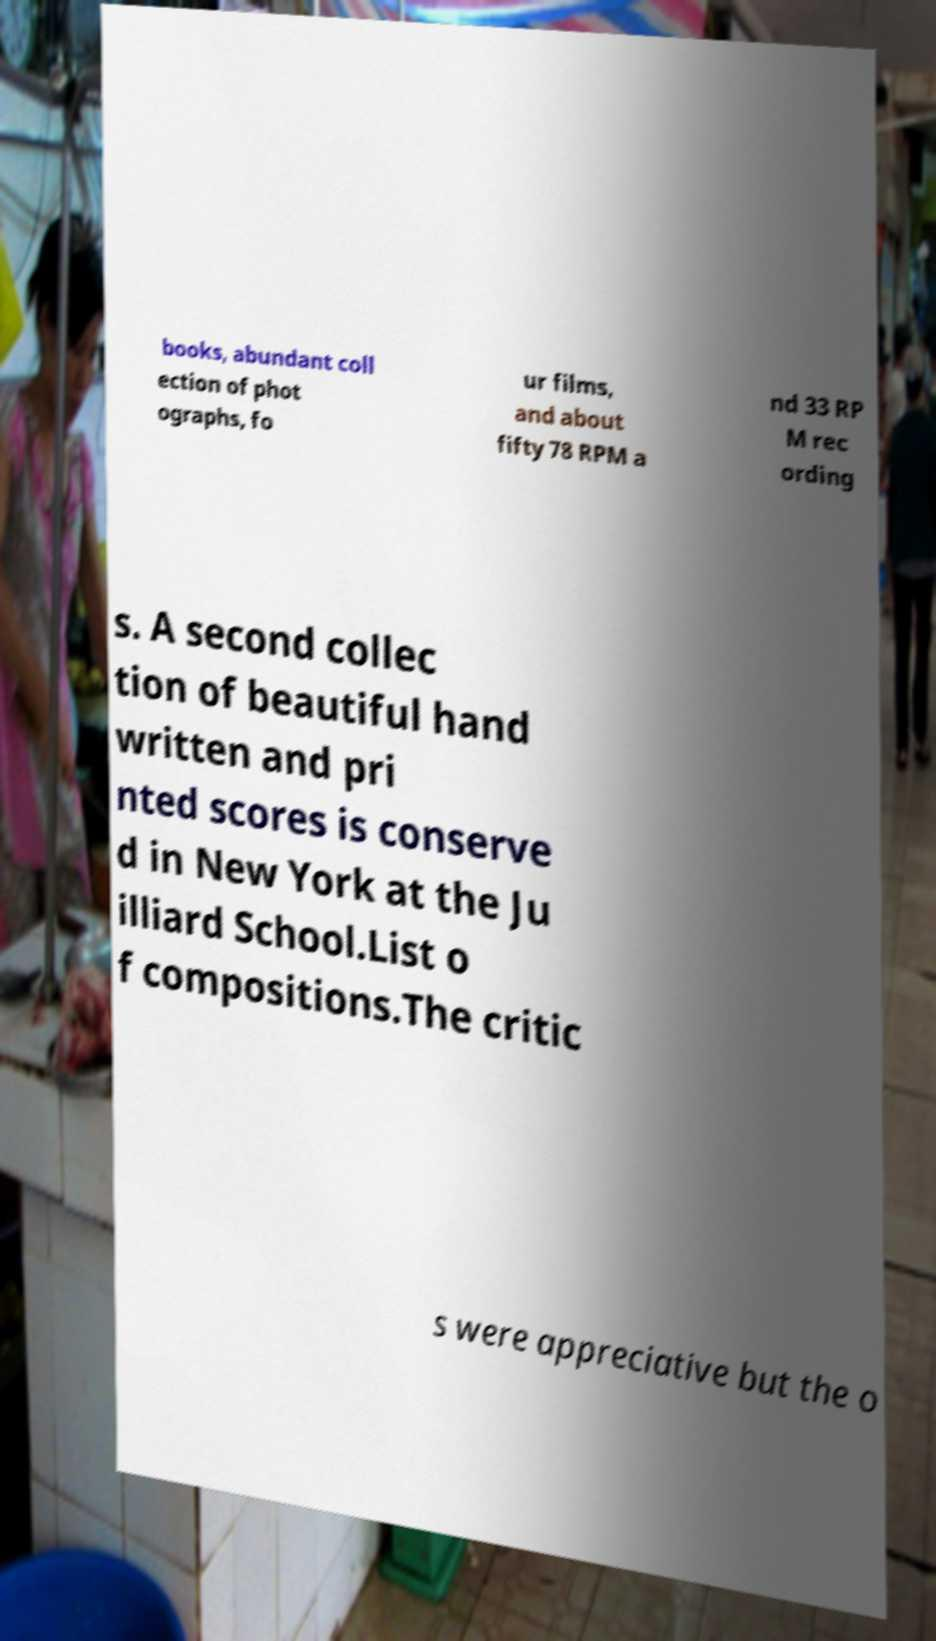For documentation purposes, I need the text within this image transcribed. Could you provide that? books, abundant coll ection of phot ographs, fo ur films, and about fifty 78 RPM a nd 33 RP M rec ording s. A second collec tion of beautiful hand written and pri nted scores is conserve d in New York at the Ju illiard School.List o f compositions.The critic s were appreciative but the o 